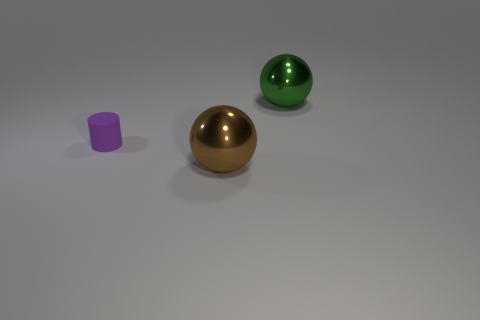Add 3 large red blocks. How many objects exist? 6 Subtract all cylinders. How many objects are left? 2 Subtract 1 spheres. How many spheres are left? 1 Add 3 big gray metal objects. How many big gray metal objects exist? 3 Subtract all green balls. How many balls are left? 1 Subtract 0 gray cylinders. How many objects are left? 3 Subtract all yellow spheres. Subtract all purple cylinders. How many spheres are left? 2 Subtract all blue blocks. How many brown balls are left? 1 Subtract all big brown balls. Subtract all big red matte cubes. How many objects are left? 2 Add 1 green balls. How many green balls are left? 2 